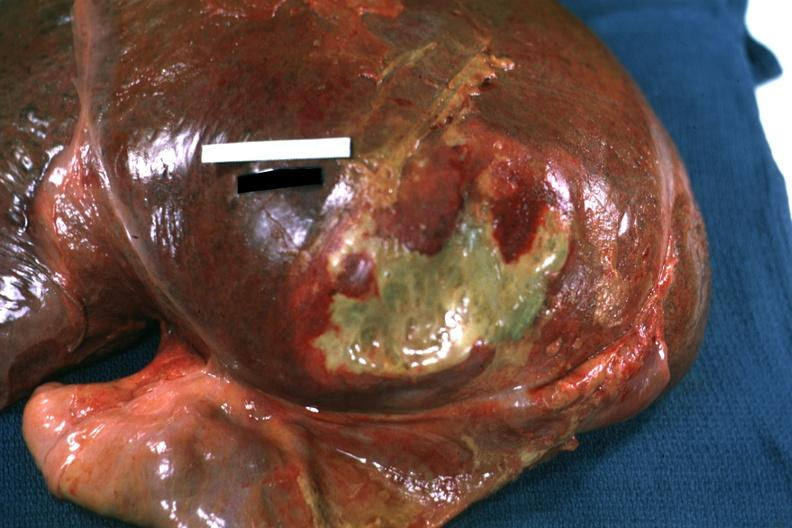s right leaf of diaphragm reflected to show flat mass of yellow green pus quite good example?
Answer the question using a single word or phrase. Yes 